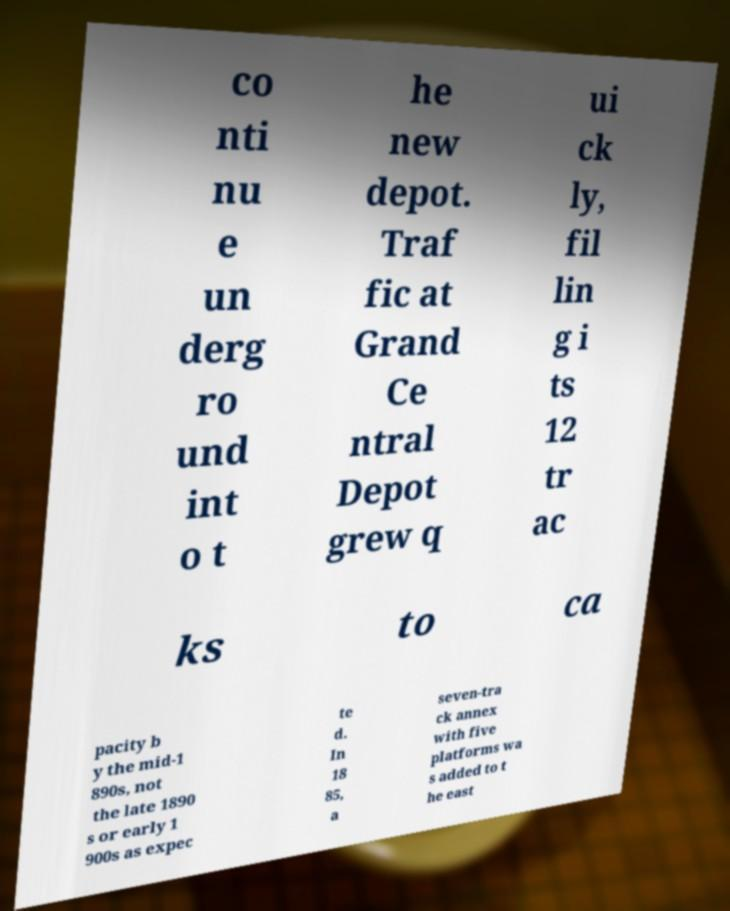I need the written content from this picture converted into text. Can you do that? co nti nu e un derg ro und int o t he new depot. Traf fic at Grand Ce ntral Depot grew q ui ck ly, fil lin g i ts 12 tr ac ks to ca pacity b y the mid-1 890s, not the late 1890 s or early 1 900s as expec te d. In 18 85, a seven-tra ck annex with five platforms wa s added to t he east 